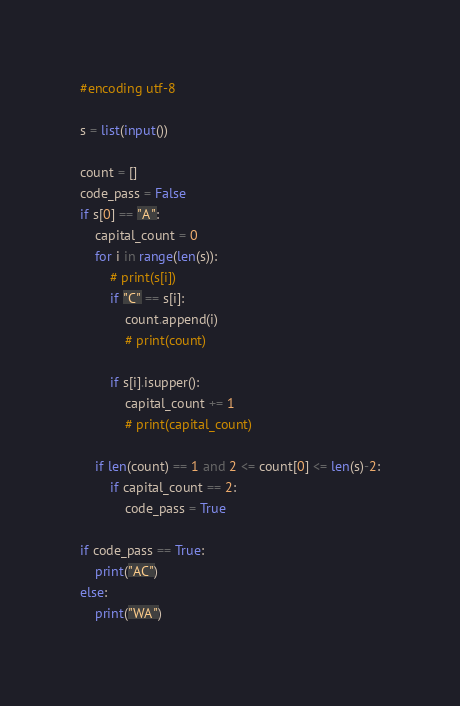<code> <loc_0><loc_0><loc_500><loc_500><_Python_>#encoding utf-8

s = list(input())

count = []
code_pass = False
if s[0] == "A":
    capital_count = 0
    for i in range(len(s)):
        # print(s[i])
        if "C" == s[i]:
            count.append(i)
            # print(count)

        if s[i].isupper():
            capital_count += 1
            # print(capital_count)

    if len(count) == 1 and 2 <= count[0] <= len(s)-2:
        if capital_count == 2:
            code_pass = True

if code_pass == True:
    print("AC")
else:
    print("WA")
</code> 